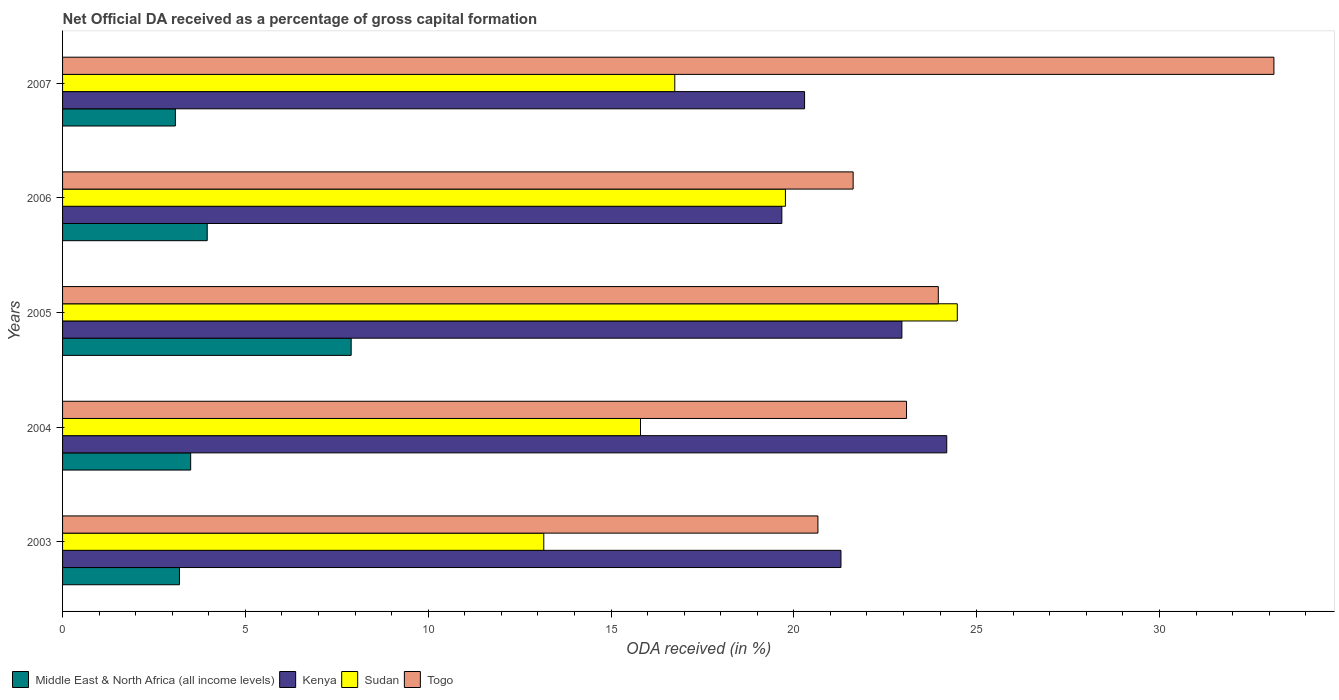How many groups of bars are there?
Offer a very short reply. 5. How many bars are there on the 5th tick from the top?
Give a very brief answer. 4. What is the label of the 4th group of bars from the top?
Offer a terse response. 2004. In how many cases, is the number of bars for a given year not equal to the number of legend labels?
Your answer should be very brief. 0. What is the net ODA received in Togo in 2005?
Offer a very short reply. 23.95. Across all years, what is the maximum net ODA received in Sudan?
Offer a terse response. 24.47. Across all years, what is the minimum net ODA received in Kenya?
Offer a terse response. 19.67. What is the total net ODA received in Kenya in the graph?
Your answer should be very brief. 108.4. What is the difference between the net ODA received in Sudan in 2004 and that in 2007?
Offer a terse response. -0.94. What is the difference between the net ODA received in Togo in 2006 and the net ODA received in Kenya in 2005?
Make the answer very short. -1.33. What is the average net ODA received in Togo per year?
Your answer should be compact. 24.49. In the year 2007, what is the difference between the net ODA received in Kenya and net ODA received in Togo?
Ensure brevity in your answer.  -12.84. What is the ratio of the net ODA received in Kenya in 2004 to that in 2005?
Provide a succinct answer. 1.05. Is the difference between the net ODA received in Kenya in 2004 and 2006 greater than the difference between the net ODA received in Togo in 2004 and 2006?
Offer a very short reply. Yes. What is the difference between the highest and the second highest net ODA received in Togo?
Provide a short and direct response. 9.18. What is the difference between the highest and the lowest net ODA received in Togo?
Give a very brief answer. 12.47. In how many years, is the net ODA received in Kenya greater than the average net ODA received in Kenya taken over all years?
Provide a succinct answer. 2. Is the sum of the net ODA received in Middle East & North Africa (all income levels) in 2005 and 2007 greater than the maximum net ODA received in Kenya across all years?
Offer a very short reply. No. What does the 4th bar from the top in 2004 represents?
Provide a succinct answer. Middle East & North Africa (all income levels). What does the 2nd bar from the bottom in 2005 represents?
Keep it short and to the point. Kenya. Is it the case that in every year, the sum of the net ODA received in Togo and net ODA received in Middle East & North Africa (all income levels) is greater than the net ODA received in Sudan?
Your response must be concise. Yes. How many bars are there?
Your response must be concise. 20. How many years are there in the graph?
Your answer should be very brief. 5. What is the difference between two consecutive major ticks on the X-axis?
Offer a very short reply. 5. Are the values on the major ticks of X-axis written in scientific E-notation?
Provide a succinct answer. No. Does the graph contain grids?
Ensure brevity in your answer.  No. How many legend labels are there?
Provide a short and direct response. 4. What is the title of the graph?
Offer a terse response. Net Official DA received as a percentage of gross capital formation. What is the label or title of the X-axis?
Your response must be concise. ODA received (in %). What is the label or title of the Y-axis?
Your answer should be compact. Years. What is the ODA received (in %) in Middle East & North Africa (all income levels) in 2003?
Your response must be concise. 3.2. What is the ODA received (in %) in Kenya in 2003?
Make the answer very short. 21.29. What is the ODA received (in %) in Sudan in 2003?
Your answer should be very brief. 13.16. What is the ODA received (in %) of Togo in 2003?
Your response must be concise. 20.66. What is the ODA received (in %) in Middle East & North Africa (all income levels) in 2004?
Offer a very short reply. 3.5. What is the ODA received (in %) in Kenya in 2004?
Your response must be concise. 24.18. What is the ODA received (in %) in Sudan in 2004?
Make the answer very short. 15.81. What is the ODA received (in %) in Togo in 2004?
Give a very brief answer. 23.08. What is the ODA received (in %) in Middle East & North Africa (all income levels) in 2005?
Keep it short and to the point. 7.89. What is the ODA received (in %) of Kenya in 2005?
Your response must be concise. 22.96. What is the ODA received (in %) of Sudan in 2005?
Give a very brief answer. 24.47. What is the ODA received (in %) in Togo in 2005?
Offer a very short reply. 23.95. What is the ODA received (in %) in Middle East & North Africa (all income levels) in 2006?
Your answer should be compact. 3.96. What is the ODA received (in %) of Kenya in 2006?
Keep it short and to the point. 19.67. What is the ODA received (in %) of Sudan in 2006?
Make the answer very short. 19.77. What is the ODA received (in %) of Togo in 2006?
Your response must be concise. 21.62. What is the ODA received (in %) of Middle East & North Africa (all income levels) in 2007?
Give a very brief answer. 3.09. What is the ODA received (in %) in Kenya in 2007?
Provide a succinct answer. 20.29. What is the ODA received (in %) in Sudan in 2007?
Provide a succinct answer. 16.74. What is the ODA received (in %) in Togo in 2007?
Ensure brevity in your answer.  33.13. Across all years, what is the maximum ODA received (in %) of Middle East & North Africa (all income levels)?
Keep it short and to the point. 7.89. Across all years, what is the maximum ODA received (in %) in Kenya?
Offer a very short reply. 24.18. Across all years, what is the maximum ODA received (in %) in Sudan?
Your response must be concise. 24.47. Across all years, what is the maximum ODA received (in %) of Togo?
Provide a succinct answer. 33.13. Across all years, what is the minimum ODA received (in %) of Middle East & North Africa (all income levels)?
Ensure brevity in your answer.  3.09. Across all years, what is the minimum ODA received (in %) in Kenya?
Keep it short and to the point. 19.67. Across all years, what is the minimum ODA received (in %) of Sudan?
Offer a terse response. 13.16. Across all years, what is the minimum ODA received (in %) in Togo?
Offer a terse response. 20.66. What is the total ODA received (in %) in Middle East & North Africa (all income levels) in the graph?
Your answer should be very brief. 21.64. What is the total ODA received (in %) of Kenya in the graph?
Offer a terse response. 108.4. What is the total ODA received (in %) in Sudan in the graph?
Your answer should be compact. 89.95. What is the total ODA received (in %) of Togo in the graph?
Your answer should be compact. 122.45. What is the difference between the ODA received (in %) in Middle East & North Africa (all income levels) in 2003 and that in 2004?
Offer a terse response. -0.31. What is the difference between the ODA received (in %) of Kenya in 2003 and that in 2004?
Ensure brevity in your answer.  -2.89. What is the difference between the ODA received (in %) of Sudan in 2003 and that in 2004?
Offer a very short reply. -2.65. What is the difference between the ODA received (in %) in Togo in 2003 and that in 2004?
Offer a very short reply. -2.42. What is the difference between the ODA received (in %) of Middle East & North Africa (all income levels) in 2003 and that in 2005?
Your answer should be compact. -4.7. What is the difference between the ODA received (in %) of Kenya in 2003 and that in 2005?
Offer a terse response. -1.67. What is the difference between the ODA received (in %) of Sudan in 2003 and that in 2005?
Ensure brevity in your answer.  -11.31. What is the difference between the ODA received (in %) in Togo in 2003 and that in 2005?
Your answer should be very brief. -3.29. What is the difference between the ODA received (in %) in Middle East & North Africa (all income levels) in 2003 and that in 2006?
Offer a very short reply. -0.76. What is the difference between the ODA received (in %) in Kenya in 2003 and that in 2006?
Give a very brief answer. 1.62. What is the difference between the ODA received (in %) in Sudan in 2003 and that in 2006?
Ensure brevity in your answer.  -6.61. What is the difference between the ODA received (in %) in Togo in 2003 and that in 2006?
Keep it short and to the point. -0.96. What is the difference between the ODA received (in %) in Middle East & North Africa (all income levels) in 2003 and that in 2007?
Give a very brief answer. 0.11. What is the difference between the ODA received (in %) of Kenya in 2003 and that in 2007?
Offer a terse response. 1. What is the difference between the ODA received (in %) in Sudan in 2003 and that in 2007?
Your answer should be compact. -3.58. What is the difference between the ODA received (in %) in Togo in 2003 and that in 2007?
Your answer should be compact. -12.47. What is the difference between the ODA received (in %) of Middle East & North Africa (all income levels) in 2004 and that in 2005?
Ensure brevity in your answer.  -4.39. What is the difference between the ODA received (in %) in Kenya in 2004 and that in 2005?
Your response must be concise. 1.23. What is the difference between the ODA received (in %) of Sudan in 2004 and that in 2005?
Your response must be concise. -8.66. What is the difference between the ODA received (in %) in Togo in 2004 and that in 2005?
Your answer should be very brief. -0.87. What is the difference between the ODA received (in %) in Middle East & North Africa (all income levels) in 2004 and that in 2006?
Make the answer very short. -0.45. What is the difference between the ODA received (in %) in Kenya in 2004 and that in 2006?
Offer a terse response. 4.51. What is the difference between the ODA received (in %) in Sudan in 2004 and that in 2006?
Your answer should be compact. -3.96. What is the difference between the ODA received (in %) in Togo in 2004 and that in 2006?
Your answer should be compact. 1.46. What is the difference between the ODA received (in %) in Middle East & North Africa (all income levels) in 2004 and that in 2007?
Provide a succinct answer. 0.42. What is the difference between the ODA received (in %) of Kenya in 2004 and that in 2007?
Your response must be concise. 3.89. What is the difference between the ODA received (in %) of Sudan in 2004 and that in 2007?
Give a very brief answer. -0.94. What is the difference between the ODA received (in %) in Togo in 2004 and that in 2007?
Keep it short and to the point. -10.05. What is the difference between the ODA received (in %) of Middle East & North Africa (all income levels) in 2005 and that in 2006?
Make the answer very short. 3.94. What is the difference between the ODA received (in %) in Kenya in 2005 and that in 2006?
Make the answer very short. 3.28. What is the difference between the ODA received (in %) of Sudan in 2005 and that in 2006?
Provide a succinct answer. 4.7. What is the difference between the ODA received (in %) of Togo in 2005 and that in 2006?
Keep it short and to the point. 2.33. What is the difference between the ODA received (in %) in Middle East & North Africa (all income levels) in 2005 and that in 2007?
Your response must be concise. 4.81. What is the difference between the ODA received (in %) of Kenya in 2005 and that in 2007?
Keep it short and to the point. 2.66. What is the difference between the ODA received (in %) of Sudan in 2005 and that in 2007?
Provide a succinct answer. 7.73. What is the difference between the ODA received (in %) in Togo in 2005 and that in 2007?
Your response must be concise. -9.18. What is the difference between the ODA received (in %) in Middle East & North Africa (all income levels) in 2006 and that in 2007?
Give a very brief answer. 0.87. What is the difference between the ODA received (in %) of Kenya in 2006 and that in 2007?
Your response must be concise. -0.62. What is the difference between the ODA received (in %) of Sudan in 2006 and that in 2007?
Give a very brief answer. 3.03. What is the difference between the ODA received (in %) of Togo in 2006 and that in 2007?
Your response must be concise. -11.51. What is the difference between the ODA received (in %) of Middle East & North Africa (all income levels) in 2003 and the ODA received (in %) of Kenya in 2004?
Your answer should be compact. -20.99. What is the difference between the ODA received (in %) of Middle East & North Africa (all income levels) in 2003 and the ODA received (in %) of Sudan in 2004?
Your answer should be compact. -12.61. What is the difference between the ODA received (in %) of Middle East & North Africa (all income levels) in 2003 and the ODA received (in %) of Togo in 2004?
Offer a very short reply. -19.89. What is the difference between the ODA received (in %) of Kenya in 2003 and the ODA received (in %) of Sudan in 2004?
Your answer should be very brief. 5.48. What is the difference between the ODA received (in %) of Kenya in 2003 and the ODA received (in %) of Togo in 2004?
Provide a short and direct response. -1.79. What is the difference between the ODA received (in %) in Sudan in 2003 and the ODA received (in %) in Togo in 2004?
Your answer should be compact. -9.92. What is the difference between the ODA received (in %) of Middle East & North Africa (all income levels) in 2003 and the ODA received (in %) of Kenya in 2005?
Provide a short and direct response. -19.76. What is the difference between the ODA received (in %) of Middle East & North Africa (all income levels) in 2003 and the ODA received (in %) of Sudan in 2005?
Your answer should be very brief. -21.27. What is the difference between the ODA received (in %) of Middle East & North Africa (all income levels) in 2003 and the ODA received (in %) of Togo in 2005?
Offer a terse response. -20.76. What is the difference between the ODA received (in %) of Kenya in 2003 and the ODA received (in %) of Sudan in 2005?
Keep it short and to the point. -3.18. What is the difference between the ODA received (in %) in Kenya in 2003 and the ODA received (in %) in Togo in 2005?
Offer a terse response. -2.66. What is the difference between the ODA received (in %) of Sudan in 2003 and the ODA received (in %) of Togo in 2005?
Ensure brevity in your answer.  -10.79. What is the difference between the ODA received (in %) in Middle East & North Africa (all income levels) in 2003 and the ODA received (in %) in Kenya in 2006?
Your answer should be compact. -16.48. What is the difference between the ODA received (in %) of Middle East & North Africa (all income levels) in 2003 and the ODA received (in %) of Sudan in 2006?
Your answer should be very brief. -16.57. What is the difference between the ODA received (in %) of Middle East & North Africa (all income levels) in 2003 and the ODA received (in %) of Togo in 2006?
Offer a terse response. -18.43. What is the difference between the ODA received (in %) in Kenya in 2003 and the ODA received (in %) in Sudan in 2006?
Your answer should be very brief. 1.52. What is the difference between the ODA received (in %) in Kenya in 2003 and the ODA received (in %) in Togo in 2006?
Provide a succinct answer. -0.33. What is the difference between the ODA received (in %) of Sudan in 2003 and the ODA received (in %) of Togo in 2006?
Provide a short and direct response. -8.46. What is the difference between the ODA received (in %) in Middle East & North Africa (all income levels) in 2003 and the ODA received (in %) in Kenya in 2007?
Your response must be concise. -17.1. What is the difference between the ODA received (in %) in Middle East & North Africa (all income levels) in 2003 and the ODA received (in %) in Sudan in 2007?
Your answer should be very brief. -13.55. What is the difference between the ODA received (in %) in Middle East & North Africa (all income levels) in 2003 and the ODA received (in %) in Togo in 2007?
Your answer should be compact. -29.93. What is the difference between the ODA received (in %) of Kenya in 2003 and the ODA received (in %) of Sudan in 2007?
Give a very brief answer. 4.55. What is the difference between the ODA received (in %) of Kenya in 2003 and the ODA received (in %) of Togo in 2007?
Your answer should be very brief. -11.84. What is the difference between the ODA received (in %) in Sudan in 2003 and the ODA received (in %) in Togo in 2007?
Your answer should be compact. -19.97. What is the difference between the ODA received (in %) in Middle East & North Africa (all income levels) in 2004 and the ODA received (in %) in Kenya in 2005?
Keep it short and to the point. -19.45. What is the difference between the ODA received (in %) of Middle East & North Africa (all income levels) in 2004 and the ODA received (in %) of Sudan in 2005?
Make the answer very short. -20.97. What is the difference between the ODA received (in %) in Middle East & North Africa (all income levels) in 2004 and the ODA received (in %) in Togo in 2005?
Offer a very short reply. -20.45. What is the difference between the ODA received (in %) in Kenya in 2004 and the ODA received (in %) in Sudan in 2005?
Offer a terse response. -0.29. What is the difference between the ODA received (in %) in Kenya in 2004 and the ODA received (in %) in Togo in 2005?
Your answer should be very brief. 0.23. What is the difference between the ODA received (in %) of Sudan in 2004 and the ODA received (in %) of Togo in 2005?
Your response must be concise. -8.15. What is the difference between the ODA received (in %) in Middle East & North Africa (all income levels) in 2004 and the ODA received (in %) in Kenya in 2006?
Your answer should be very brief. -16.17. What is the difference between the ODA received (in %) in Middle East & North Africa (all income levels) in 2004 and the ODA received (in %) in Sudan in 2006?
Offer a terse response. -16.27. What is the difference between the ODA received (in %) of Middle East & North Africa (all income levels) in 2004 and the ODA received (in %) of Togo in 2006?
Offer a terse response. -18.12. What is the difference between the ODA received (in %) of Kenya in 2004 and the ODA received (in %) of Sudan in 2006?
Your response must be concise. 4.41. What is the difference between the ODA received (in %) of Kenya in 2004 and the ODA received (in %) of Togo in 2006?
Make the answer very short. 2.56. What is the difference between the ODA received (in %) of Sudan in 2004 and the ODA received (in %) of Togo in 2006?
Your answer should be compact. -5.82. What is the difference between the ODA received (in %) in Middle East & North Africa (all income levels) in 2004 and the ODA received (in %) in Kenya in 2007?
Your response must be concise. -16.79. What is the difference between the ODA received (in %) of Middle East & North Africa (all income levels) in 2004 and the ODA received (in %) of Sudan in 2007?
Keep it short and to the point. -13.24. What is the difference between the ODA received (in %) in Middle East & North Africa (all income levels) in 2004 and the ODA received (in %) in Togo in 2007?
Ensure brevity in your answer.  -29.63. What is the difference between the ODA received (in %) in Kenya in 2004 and the ODA received (in %) in Sudan in 2007?
Provide a succinct answer. 7.44. What is the difference between the ODA received (in %) in Kenya in 2004 and the ODA received (in %) in Togo in 2007?
Offer a very short reply. -8.95. What is the difference between the ODA received (in %) in Sudan in 2004 and the ODA received (in %) in Togo in 2007?
Make the answer very short. -17.32. What is the difference between the ODA received (in %) of Middle East & North Africa (all income levels) in 2005 and the ODA received (in %) of Kenya in 2006?
Provide a succinct answer. -11.78. What is the difference between the ODA received (in %) of Middle East & North Africa (all income levels) in 2005 and the ODA received (in %) of Sudan in 2006?
Offer a terse response. -11.88. What is the difference between the ODA received (in %) in Middle East & North Africa (all income levels) in 2005 and the ODA received (in %) in Togo in 2006?
Provide a short and direct response. -13.73. What is the difference between the ODA received (in %) in Kenya in 2005 and the ODA received (in %) in Sudan in 2006?
Give a very brief answer. 3.19. What is the difference between the ODA received (in %) in Kenya in 2005 and the ODA received (in %) in Togo in 2006?
Provide a short and direct response. 1.33. What is the difference between the ODA received (in %) of Sudan in 2005 and the ODA received (in %) of Togo in 2006?
Offer a very short reply. 2.85. What is the difference between the ODA received (in %) in Middle East & North Africa (all income levels) in 2005 and the ODA received (in %) in Kenya in 2007?
Your answer should be very brief. -12.4. What is the difference between the ODA received (in %) in Middle East & North Africa (all income levels) in 2005 and the ODA received (in %) in Sudan in 2007?
Your answer should be very brief. -8.85. What is the difference between the ODA received (in %) in Middle East & North Africa (all income levels) in 2005 and the ODA received (in %) in Togo in 2007?
Offer a very short reply. -25.24. What is the difference between the ODA received (in %) of Kenya in 2005 and the ODA received (in %) of Sudan in 2007?
Your answer should be very brief. 6.21. What is the difference between the ODA received (in %) in Kenya in 2005 and the ODA received (in %) in Togo in 2007?
Give a very brief answer. -10.18. What is the difference between the ODA received (in %) of Sudan in 2005 and the ODA received (in %) of Togo in 2007?
Ensure brevity in your answer.  -8.66. What is the difference between the ODA received (in %) of Middle East & North Africa (all income levels) in 2006 and the ODA received (in %) of Kenya in 2007?
Ensure brevity in your answer.  -16.34. What is the difference between the ODA received (in %) of Middle East & North Africa (all income levels) in 2006 and the ODA received (in %) of Sudan in 2007?
Ensure brevity in your answer.  -12.79. What is the difference between the ODA received (in %) in Middle East & North Africa (all income levels) in 2006 and the ODA received (in %) in Togo in 2007?
Your response must be concise. -29.17. What is the difference between the ODA received (in %) of Kenya in 2006 and the ODA received (in %) of Sudan in 2007?
Make the answer very short. 2.93. What is the difference between the ODA received (in %) of Kenya in 2006 and the ODA received (in %) of Togo in 2007?
Your answer should be compact. -13.46. What is the difference between the ODA received (in %) of Sudan in 2006 and the ODA received (in %) of Togo in 2007?
Your answer should be compact. -13.36. What is the average ODA received (in %) of Middle East & North Africa (all income levels) per year?
Your answer should be compact. 4.33. What is the average ODA received (in %) of Kenya per year?
Your response must be concise. 21.68. What is the average ODA received (in %) of Sudan per year?
Make the answer very short. 17.99. What is the average ODA received (in %) in Togo per year?
Ensure brevity in your answer.  24.49. In the year 2003, what is the difference between the ODA received (in %) in Middle East & North Africa (all income levels) and ODA received (in %) in Kenya?
Keep it short and to the point. -18.09. In the year 2003, what is the difference between the ODA received (in %) in Middle East & North Africa (all income levels) and ODA received (in %) in Sudan?
Make the answer very short. -9.96. In the year 2003, what is the difference between the ODA received (in %) in Middle East & North Africa (all income levels) and ODA received (in %) in Togo?
Make the answer very short. -17.46. In the year 2003, what is the difference between the ODA received (in %) of Kenya and ODA received (in %) of Sudan?
Offer a very short reply. 8.13. In the year 2003, what is the difference between the ODA received (in %) of Kenya and ODA received (in %) of Togo?
Provide a short and direct response. 0.63. In the year 2003, what is the difference between the ODA received (in %) of Sudan and ODA received (in %) of Togo?
Provide a short and direct response. -7.5. In the year 2004, what is the difference between the ODA received (in %) in Middle East & North Africa (all income levels) and ODA received (in %) in Kenya?
Your answer should be very brief. -20.68. In the year 2004, what is the difference between the ODA received (in %) of Middle East & North Africa (all income levels) and ODA received (in %) of Sudan?
Make the answer very short. -12.3. In the year 2004, what is the difference between the ODA received (in %) in Middle East & North Africa (all income levels) and ODA received (in %) in Togo?
Provide a short and direct response. -19.58. In the year 2004, what is the difference between the ODA received (in %) in Kenya and ODA received (in %) in Sudan?
Your answer should be very brief. 8.38. In the year 2004, what is the difference between the ODA received (in %) of Kenya and ODA received (in %) of Togo?
Offer a very short reply. 1.1. In the year 2004, what is the difference between the ODA received (in %) in Sudan and ODA received (in %) in Togo?
Make the answer very short. -7.28. In the year 2005, what is the difference between the ODA received (in %) in Middle East & North Africa (all income levels) and ODA received (in %) in Kenya?
Make the answer very short. -15.06. In the year 2005, what is the difference between the ODA received (in %) in Middle East & North Africa (all income levels) and ODA received (in %) in Sudan?
Your answer should be compact. -16.58. In the year 2005, what is the difference between the ODA received (in %) in Middle East & North Africa (all income levels) and ODA received (in %) in Togo?
Your answer should be very brief. -16.06. In the year 2005, what is the difference between the ODA received (in %) in Kenya and ODA received (in %) in Sudan?
Provide a succinct answer. -1.52. In the year 2005, what is the difference between the ODA received (in %) of Kenya and ODA received (in %) of Togo?
Ensure brevity in your answer.  -1. In the year 2005, what is the difference between the ODA received (in %) of Sudan and ODA received (in %) of Togo?
Offer a terse response. 0.52. In the year 2006, what is the difference between the ODA received (in %) in Middle East & North Africa (all income levels) and ODA received (in %) in Kenya?
Provide a succinct answer. -15.72. In the year 2006, what is the difference between the ODA received (in %) in Middle East & North Africa (all income levels) and ODA received (in %) in Sudan?
Your answer should be compact. -15.81. In the year 2006, what is the difference between the ODA received (in %) in Middle East & North Africa (all income levels) and ODA received (in %) in Togo?
Offer a terse response. -17.67. In the year 2006, what is the difference between the ODA received (in %) in Kenya and ODA received (in %) in Sudan?
Offer a very short reply. -0.1. In the year 2006, what is the difference between the ODA received (in %) in Kenya and ODA received (in %) in Togo?
Ensure brevity in your answer.  -1.95. In the year 2006, what is the difference between the ODA received (in %) of Sudan and ODA received (in %) of Togo?
Keep it short and to the point. -1.85. In the year 2007, what is the difference between the ODA received (in %) in Middle East & North Africa (all income levels) and ODA received (in %) in Kenya?
Give a very brief answer. -17.21. In the year 2007, what is the difference between the ODA received (in %) in Middle East & North Africa (all income levels) and ODA received (in %) in Sudan?
Your answer should be compact. -13.66. In the year 2007, what is the difference between the ODA received (in %) of Middle East & North Africa (all income levels) and ODA received (in %) of Togo?
Offer a very short reply. -30.05. In the year 2007, what is the difference between the ODA received (in %) of Kenya and ODA received (in %) of Sudan?
Make the answer very short. 3.55. In the year 2007, what is the difference between the ODA received (in %) in Kenya and ODA received (in %) in Togo?
Provide a succinct answer. -12.84. In the year 2007, what is the difference between the ODA received (in %) of Sudan and ODA received (in %) of Togo?
Ensure brevity in your answer.  -16.39. What is the ratio of the ODA received (in %) of Middle East & North Africa (all income levels) in 2003 to that in 2004?
Ensure brevity in your answer.  0.91. What is the ratio of the ODA received (in %) in Kenya in 2003 to that in 2004?
Make the answer very short. 0.88. What is the ratio of the ODA received (in %) of Sudan in 2003 to that in 2004?
Give a very brief answer. 0.83. What is the ratio of the ODA received (in %) in Togo in 2003 to that in 2004?
Offer a terse response. 0.9. What is the ratio of the ODA received (in %) in Middle East & North Africa (all income levels) in 2003 to that in 2005?
Make the answer very short. 0.41. What is the ratio of the ODA received (in %) in Kenya in 2003 to that in 2005?
Offer a very short reply. 0.93. What is the ratio of the ODA received (in %) of Sudan in 2003 to that in 2005?
Keep it short and to the point. 0.54. What is the ratio of the ODA received (in %) of Togo in 2003 to that in 2005?
Your answer should be very brief. 0.86. What is the ratio of the ODA received (in %) in Middle East & North Africa (all income levels) in 2003 to that in 2006?
Make the answer very short. 0.81. What is the ratio of the ODA received (in %) of Kenya in 2003 to that in 2006?
Provide a short and direct response. 1.08. What is the ratio of the ODA received (in %) in Sudan in 2003 to that in 2006?
Provide a succinct answer. 0.67. What is the ratio of the ODA received (in %) in Togo in 2003 to that in 2006?
Your response must be concise. 0.96. What is the ratio of the ODA received (in %) of Middle East & North Africa (all income levels) in 2003 to that in 2007?
Offer a very short reply. 1.04. What is the ratio of the ODA received (in %) in Kenya in 2003 to that in 2007?
Ensure brevity in your answer.  1.05. What is the ratio of the ODA received (in %) of Sudan in 2003 to that in 2007?
Your response must be concise. 0.79. What is the ratio of the ODA received (in %) in Togo in 2003 to that in 2007?
Your response must be concise. 0.62. What is the ratio of the ODA received (in %) in Middle East & North Africa (all income levels) in 2004 to that in 2005?
Ensure brevity in your answer.  0.44. What is the ratio of the ODA received (in %) in Kenya in 2004 to that in 2005?
Offer a very short reply. 1.05. What is the ratio of the ODA received (in %) of Sudan in 2004 to that in 2005?
Your response must be concise. 0.65. What is the ratio of the ODA received (in %) of Togo in 2004 to that in 2005?
Provide a succinct answer. 0.96. What is the ratio of the ODA received (in %) in Middle East & North Africa (all income levels) in 2004 to that in 2006?
Ensure brevity in your answer.  0.89. What is the ratio of the ODA received (in %) in Kenya in 2004 to that in 2006?
Provide a succinct answer. 1.23. What is the ratio of the ODA received (in %) in Sudan in 2004 to that in 2006?
Offer a very short reply. 0.8. What is the ratio of the ODA received (in %) of Togo in 2004 to that in 2006?
Give a very brief answer. 1.07. What is the ratio of the ODA received (in %) of Middle East & North Africa (all income levels) in 2004 to that in 2007?
Keep it short and to the point. 1.14. What is the ratio of the ODA received (in %) in Kenya in 2004 to that in 2007?
Your answer should be very brief. 1.19. What is the ratio of the ODA received (in %) in Sudan in 2004 to that in 2007?
Offer a terse response. 0.94. What is the ratio of the ODA received (in %) in Togo in 2004 to that in 2007?
Offer a terse response. 0.7. What is the ratio of the ODA received (in %) in Middle East & North Africa (all income levels) in 2005 to that in 2006?
Keep it short and to the point. 2. What is the ratio of the ODA received (in %) in Kenya in 2005 to that in 2006?
Your answer should be very brief. 1.17. What is the ratio of the ODA received (in %) of Sudan in 2005 to that in 2006?
Keep it short and to the point. 1.24. What is the ratio of the ODA received (in %) in Togo in 2005 to that in 2006?
Offer a very short reply. 1.11. What is the ratio of the ODA received (in %) of Middle East & North Africa (all income levels) in 2005 to that in 2007?
Your answer should be compact. 2.56. What is the ratio of the ODA received (in %) of Kenya in 2005 to that in 2007?
Make the answer very short. 1.13. What is the ratio of the ODA received (in %) in Sudan in 2005 to that in 2007?
Your answer should be very brief. 1.46. What is the ratio of the ODA received (in %) in Togo in 2005 to that in 2007?
Offer a terse response. 0.72. What is the ratio of the ODA received (in %) in Middle East & North Africa (all income levels) in 2006 to that in 2007?
Provide a succinct answer. 1.28. What is the ratio of the ODA received (in %) of Kenya in 2006 to that in 2007?
Make the answer very short. 0.97. What is the ratio of the ODA received (in %) in Sudan in 2006 to that in 2007?
Your answer should be compact. 1.18. What is the ratio of the ODA received (in %) in Togo in 2006 to that in 2007?
Provide a short and direct response. 0.65. What is the difference between the highest and the second highest ODA received (in %) of Middle East & North Africa (all income levels)?
Give a very brief answer. 3.94. What is the difference between the highest and the second highest ODA received (in %) in Kenya?
Offer a very short reply. 1.23. What is the difference between the highest and the second highest ODA received (in %) of Sudan?
Give a very brief answer. 4.7. What is the difference between the highest and the second highest ODA received (in %) in Togo?
Provide a succinct answer. 9.18. What is the difference between the highest and the lowest ODA received (in %) in Middle East & North Africa (all income levels)?
Provide a succinct answer. 4.81. What is the difference between the highest and the lowest ODA received (in %) in Kenya?
Give a very brief answer. 4.51. What is the difference between the highest and the lowest ODA received (in %) in Sudan?
Provide a short and direct response. 11.31. What is the difference between the highest and the lowest ODA received (in %) of Togo?
Ensure brevity in your answer.  12.47. 